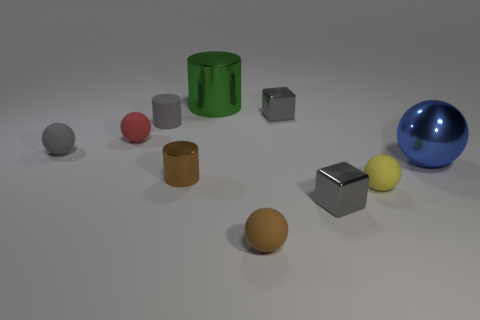Subtract all gray matte balls. How many balls are left? 4 Subtract all gray cylinders. How many cylinders are left? 2 Subtract all cylinders. How many objects are left? 7 Subtract 3 cylinders. How many cylinders are left? 0 Subtract all red spheres. How many gray cylinders are left? 1 Subtract all large gray rubber things. Subtract all blue metal things. How many objects are left? 9 Add 7 metal balls. How many metal balls are left? 8 Add 1 tiny rubber cylinders. How many tiny rubber cylinders exist? 2 Subtract 1 red balls. How many objects are left? 9 Subtract all red cylinders. Subtract all red spheres. How many cylinders are left? 3 